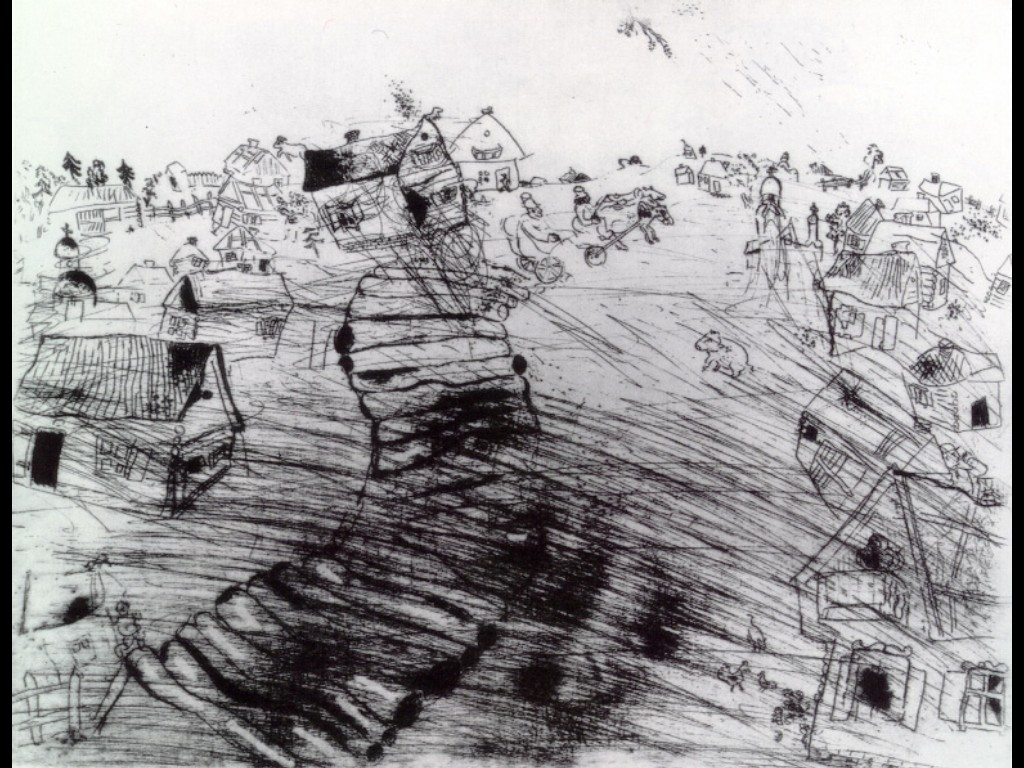Analyze the image in a comprehensive and detailed manner. The image is a captivating black and white sketch depicting a lively village scene. The expressive and loose art style, characterized by dynamic line work, suggests an approach akin to Impressionism. A large, winding road serves as the central element of the composition, bisecting the village and infusing the scene with movement and vitality.

Alongside the road, a variety of houses, trees, and villagers create a bustling atmosphere. People are depicted in various engaging activities, such as walking, riding bicycles, and children playing, each detail contributing to the sense of a chaotic yet lively community. The hustle and bustle of daily life is captured well despite the monochromatic palette, with the intricate details and energetic strokes effectively conveying the vibrancy and dynamism of the village. The absence of color does not detract from the liveliness; instead, it emphasizes the richness in the diversity of activities and the harmonious coexistence within the community, making it a vivid portrayal of rural life. 